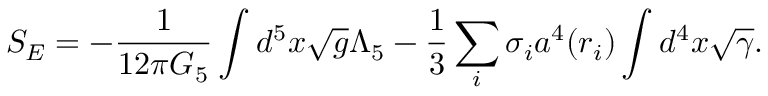Convert formula to latex. <formula><loc_0><loc_0><loc_500><loc_500>S _ { E } = - { \frac { 1 } { 1 2 \pi G _ { 5 } } } \int d ^ { 5 } x \sqrt { g } \Lambda _ { 5 } - { \frac { 1 } { 3 } } \sum _ { i } \sigma _ { i } a ^ { 4 } ( r _ { i } ) \int d ^ { 4 } x \sqrt { \gamma } .</formula> 